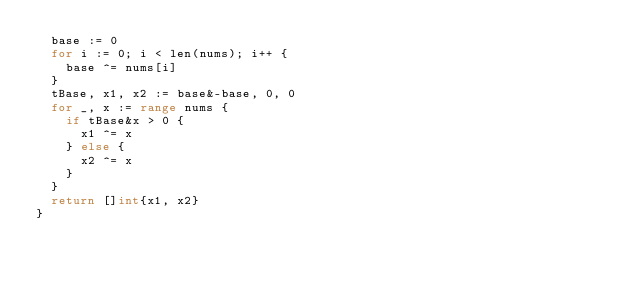Convert code to text. <code><loc_0><loc_0><loc_500><loc_500><_Go_>	base := 0
	for i := 0; i < len(nums); i++ {
		base ^= nums[i]
	}
	tBase, x1, x2 := base&-base, 0, 0
	for _, x := range nums {
		if tBase&x > 0 {
			x1 ^= x
		} else {
			x2 ^= x
		}
	}
	return []int{x1, x2}
}
</code> 